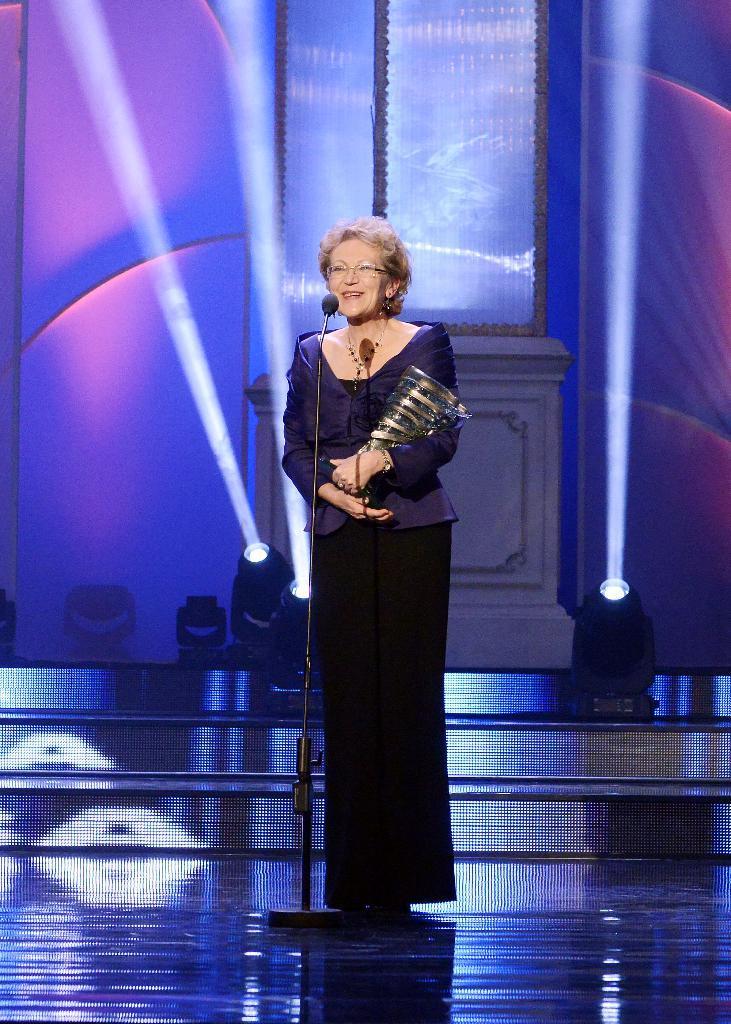In one or two sentences, can you explain what this image depicts? This image is taken indoors. At the bottom of the image there is a floor. In the background there is a wall. There are a few lights. There are a few stairs. In the middle of the image a woman is standing on the dais and she is holding a trophy in her hands and there is a mic. 